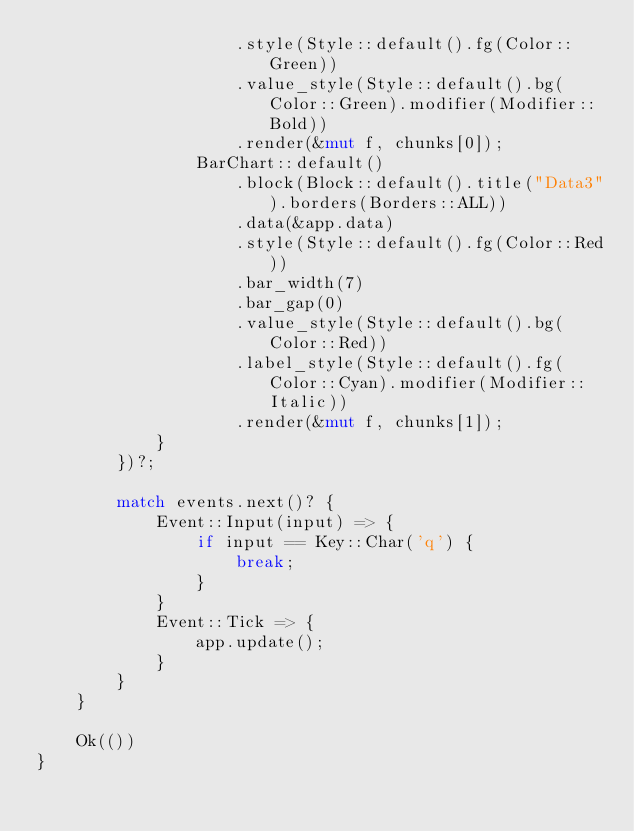<code> <loc_0><loc_0><loc_500><loc_500><_Rust_>                    .style(Style::default().fg(Color::Green))
                    .value_style(Style::default().bg(Color::Green).modifier(Modifier::Bold))
                    .render(&mut f, chunks[0]);
                BarChart::default()
                    .block(Block::default().title("Data3").borders(Borders::ALL))
                    .data(&app.data)
                    .style(Style::default().fg(Color::Red))
                    .bar_width(7)
                    .bar_gap(0)
                    .value_style(Style::default().bg(Color::Red))
                    .label_style(Style::default().fg(Color::Cyan).modifier(Modifier::Italic))
                    .render(&mut f, chunks[1]);
            }
        })?;

        match events.next()? {
            Event::Input(input) => {
                if input == Key::Char('q') {
                    break;
                }
            }
            Event::Tick => {
                app.update();
            }
        }
    }

    Ok(())
}
</code> 